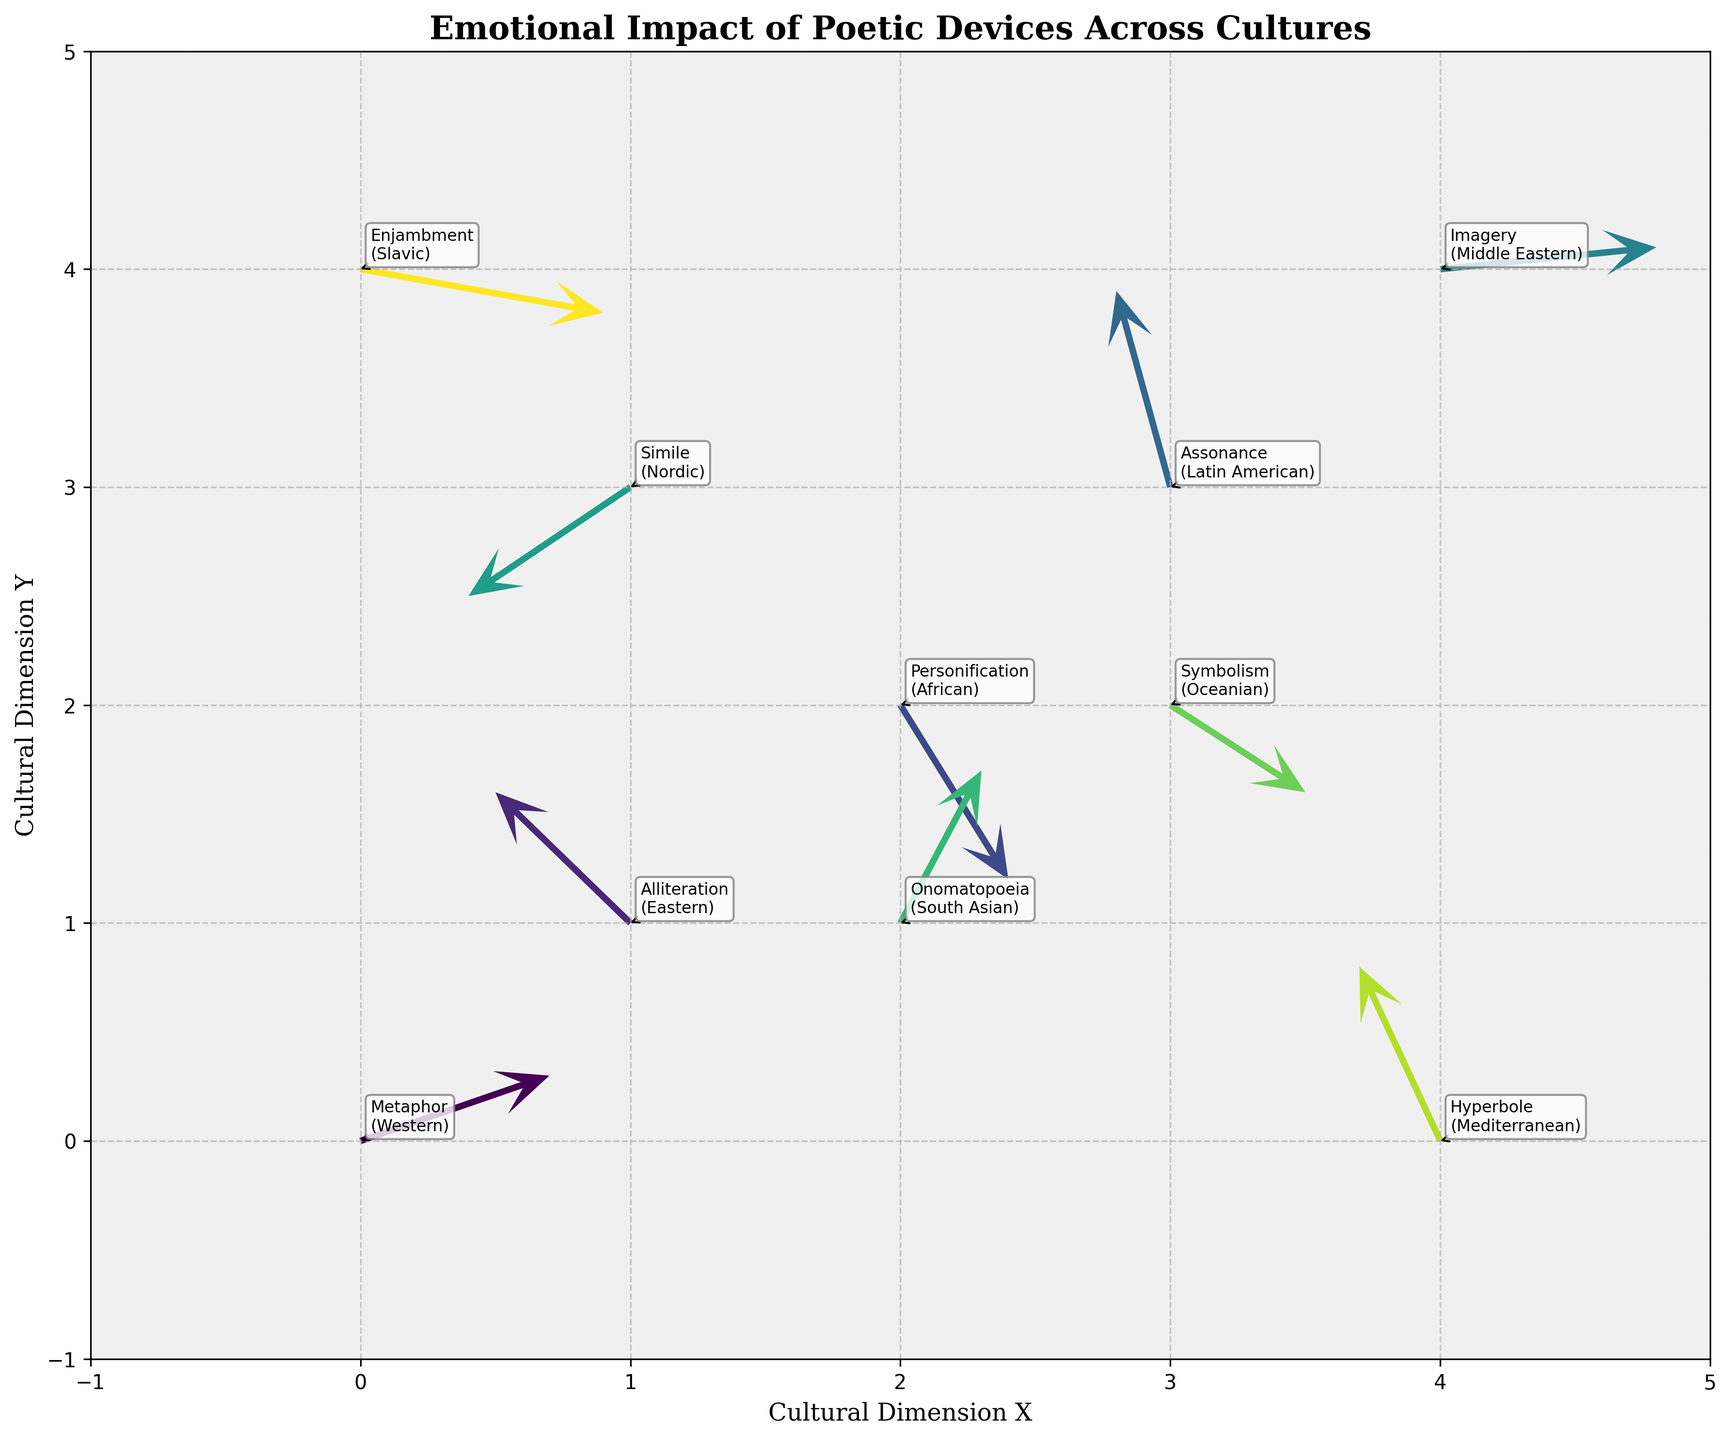What is the title of the figure? The title is located at the top of the figure and it specifies what the visualization is about.
Answer: Emotional Impact of Poetic Devices Across Cultures Which device and culture are associated with the point at (0, 0)? You can look at the annotations near each point, and for (0, 0), it reads "Metaphor (Western)."
Answer: Metaphor (Western) How many data points are displayed in the figure? By counting each point and its associated arrow in the quiver plot, you can sum them for the total.
Answer: 10 Which poetic device has the most significant downward force? Observing the directional arrows, Personification at coordinates (2, 2) has the largest downward component in its vector.
Answer: Personification Compare the horizontal force components of Enjambment and Hyperbole. Which is stronger? Enjambment has a horizontal component of 0.9, and Hyperbole has -0.3. A positive value of 0.9 is stronger than -0.3.
Answer: Enjambment Identify all the poetic devices that have a positive vertical (Y) component. How many are there? By checking the annotation tags and their vertical components, Metaphor, Alliteration, Assonance, Onomatopoeia, Simile, and Hyperbole all have positive vertical components.
Answer: 6 What is the cultural dimension of the poetic device associated with the arrow located at (3, 2)? Looking at the coordinates and corresponding annotations, the point at (3, 2) is associated with Symbolism, which has Oceanian culture.
Answer: Oceanian Which poetic device and culture combination have the highest upward (positive) force vector in the vertical direction? Checking the combination with the largest positive vertical component, Assonance (Latin American) at (3, 3) has the highest upward force.
Answer: Assonance (Latin American) What are the x and y components of the device with coordinates (1, 3)? The device at (1, 3) is Simile (Nordic), and it has components u = -0.6 and v = -0.5.
Answer: -0.6, -0.5 Average the u-components of Metaphor, Alliteration, and Personification. What is the result? The values are 0.7 (Metaphor), -0.5 (Alliteration), and 0.4 (Personification). The average is (0.7 - 0.5 + 0.4) / 3 = 0.2.
Answer: 0.2 